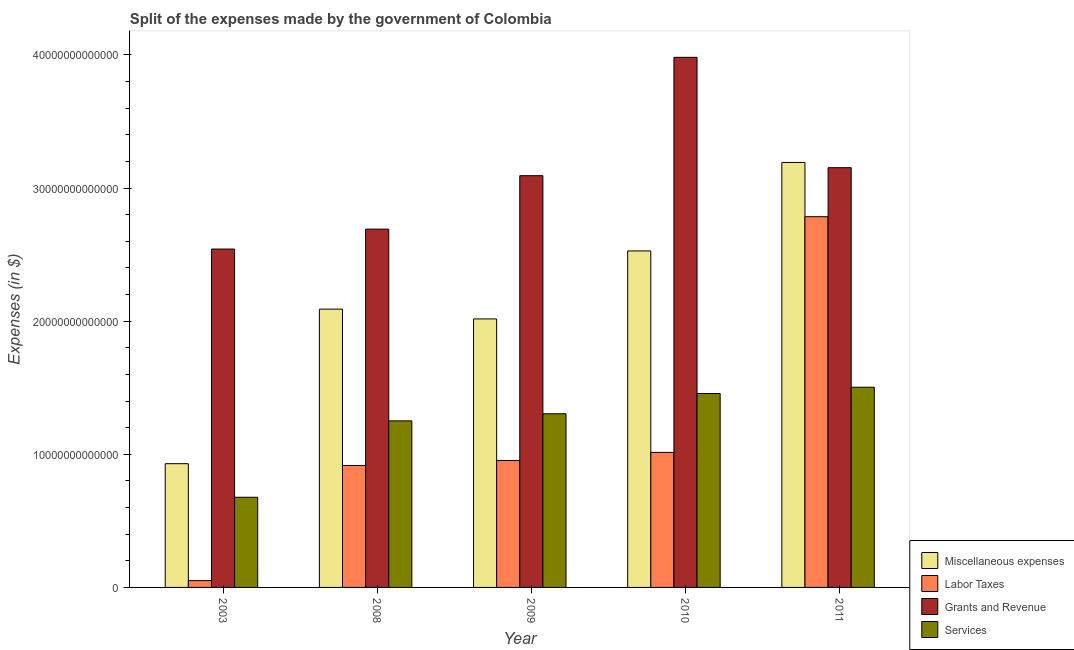How many bars are there on the 1st tick from the left?
Provide a succinct answer. 4. How many bars are there on the 5th tick from the right?
Make the answer very short. 4. In how many cases, is the number of bars for a given year not equal to the number of legend labels?
Offer a very short reply. 0. What is the amount spent on grants and revenue in 2009?
Make the answer very short. 3.09e+13. Across all years, what is the maximum amount spent on labor taxes?
Keep it short and to the point. 2.78e+13. Across all years, what is the minimum amount spent on services?
Offer a terse response. 6.77e+12. In which year was the amount spent on grants and revenue maximum?
Offer a terse response. 2010. In which year was the amount spent on miscellaneous expenses minimum?
Provide a succinct answer. 2003. What is the total amount spent on miscellaneous expenses in the graph?
Ensure brevity in your answer.  1.08e+14. What is the difference between the amount spent on services in 2003 and that in 2011?
Your answer should be very brief. -8.27e+12. What is the difference between the amount spent on miscellaneous expenses in 2008 and the amount spent on grants and revenue in 2003?
Your answer should be compact. 1.16e+13. What is the average amount spent on grants and revenue per year?
Give a very brief answer. 3.09e+13. In the year 2003, what is the difference between the amount spent on labor taxes and amount spent on grants and revenue?
Your answer should be very brief. 0. What is the ratio of the amount spent on labor taxes in 2008 to that in 2009?
Ensure brevity in your answer.  0.96. Is the amount spent on miscellaneous expenses in 2003 less than that in 2011?
Provide a succinct answer. Yes. What is the difference between the highest and the second highest amount spent on miscellaneous expenses?
Your response must be concise. 6.65e+12. What is the difference between the highest and the lowest amount spent on grants and revenue?
Give a very brief answer. 1.44e+13. In how many years, is the amount spent on services greater than the average amount spent on services taken over all years?
Keep it short and to the point. 4. Is it the case that in every year, the sum of the amount spent on services and amount spent on labor taxes is greater than the sum of amount spent on miscellaneous expenses and amount spent on grants and revenue?
Your answer should be compact. No. What does the 4th bar from the left in 2009 represents?
Your response must be concise. Services. What does the 4th bar from the right in 2008 represents?
Keep it short and to the point. Miscellaneous expenses. How many bars are there?
Provide a short and direct response. 20. How many years are there in the graph?
Your answer should be very brief. 5. What is the difference between two consecutive major ticks on the Y-axis?
Provide a short and direct response. 1.00e+13. Does the graph contain any zero values?
Offer a terse response. No. Does the graph contain grids?
Offer a very short reply. No. Where does the legend appear in the graph?
Offer a terse response. Bottom right. How many legend labels are there?
Your response must be concise. 4. How are the legend labels stacked?
Offer a terse response. Vertical. What is the title of the graph?
Offer a very short reply. Split of the expenses made by the government of Colombia. What is the label or title of the Y-axis?
Provide a short and direct response. Expenses (in $). What is the Expenses (in $) of Miscellaneous expenses in 2003?
Provide a short and direct response. 9.30e+12. What is the Expenses (in $) of Labor Taxes in 2003?
Ensure brevity in your answer.  5.11e+11. What is the Expenses (in $) of Grants and Revenue in 2003?
Ensure brevity in your answer.  2.54e+13. What is the Expenses (in $) of Services in 2003?
Give a very brief answer. 6.77e+12. What is the Expenses (in $) in Miscellaneous expenses in 2008?
Offer a terse response. 2.09e+13. What is the Expenses (in $) in Labor Taxes in 2008?
Provide a short and direct response. 9.16e+12. What is the Expenses (in $) in Grants and Revenue in 2008?
Give a very brief answer. 2.69e+13. What is the Expenses (in $) in Services in 2008?
Your response must be concise. 1.25e+13. What is the Expenses (in $) of Miscellaneous expenses in 2009?
Your answer should be very brief. 2.02e+13. What is the Expenses (in $) of Labor Taxes in 2009?
Offer a very short reply. 9.54e+12. What is the Expenses (in $) of Grants and Revenue in 2009?
Keep it short and to the point. 3.09e+13. What is the Expenses (in $) in Services in 2009?
Provide a short and direct response. 1.30e+13. What is the Expenses (in $) of Miscellaneous expenses in 2010?
Provide a succinct answer. 2.53e+13. What is the Expenses (in $) in Labor Taxes in 2010?
Make the answer very short. 1.01e+13. What is the Expenses (in $) in Grants and Revenue in 2010?
Offer a very short reply. 3.98e+13. What is the Expenses (in $) of Services in 2010?
Your answer should be compact. 1.46e+13. What is the Expenses (in $) of Miscellaneous expenses in 2011?
Your response must be concise. 3.19e+13. What is the Expenses (in $) in Labor Taxes in 2011?
Keep it short and to the point. 2.78e+13. What is the Expenses (in $) of Grants and Revenue in 2011?
Provide a short and direct response. 3.15e+13. What is the Expenses (in $) of Services in 2011?
Your response must be concise. 1.50e+13. Across all years, what is the maximum Expenses (in $) in Miscellaneous expenses?
Your answer should be compact. 3.19e+13. Across all years, what is the maximum Expenses (in $) in Labor Taxes?
Your response must be concise. 2.78e+13. Across all years, what is the maximum Expenses (in $) of Grants and Revenue?
Give a very brief answer. 3.98e+13. Across all years, what is the maximum Expenses (in $) in Services?
Keep it short and to the point. 1.50e+13. Across all years, what is the minimum Expenses (in $) of Miscellaneous expenses?
Your answer should be compact. 9.30e+12. Across all years, what is the minimum Expenses (in $) in Labor Taxes?
Your response must be concise. 5.11e+11. Across all years, what is the minimum Expenses (in $) of Grants and Revenue?
Make the answer very short. 2.54e+13. Across all years, what is the minimum Expenses (in $) in Services?
Provide a succinct answer. 6.77e+12. What is the total Expenses (in $) in Miscellaneous expenses in the graph?
Your answer should be very brief. 1.08e+14. What is the total Expenses (in $) in Labor Taxes in the graph?
Make the answer very short. 5.72e+13. What is the total Expenses (in $) in Grants and Revenue in the graph?
Give a very brief answer. 1.55e+14. What is the total Expenses (in $) in Services in the graph?
Provide a succinct answer. 6.19e+13. What is the difference between the Expenses (in $) in Miscellaneous expenses in 2003 and that in 2008?
Ensure brevity in your answer.  -1.16e+13. What is the difference between the Expenses (in $) in Labor Taxes in 2003 and that in 2008?
Provide a short and direct response. -8.65e+12. What is the difference between the Expenses (in $) in Grants and Revenue in 2003 and that in 2008?
Provide a short and direct response. -1.50e+12. What is the difference between the Expenses (in $) in Services in 2003 and that in 2008?
Your answer should be very brief. -5.74e+12. What is the difference between the Expenses (in $) in Miscellaneous expenses in 2003 and that in 2009?
Your response must be concise. -1.09e+13. What is the difference between the Expenses (in $) in Labor Taxes in 2003 and that in 2009?
Keep it short and to the point. -9.03e+12. What is the difference between the Expenses (in $) of Grants and Revenue in 2003 and that in 2009?
Make the answer very short. -5.51e+12. What is the difference between the Expenses (in $) in Services in 2003 and that in 2009?
Give a very brief answer. -6.27e+12. What is the difference between the Expenses (in $) of Miscellaneous expenses in 2003 and that in 2010?
Offer a terse response. -1.60e+13. What is the difference between the Expenses (in $) of Labor Taxes in 2003 and that in 2010?
Offer a terse response. -9.63e+12. What is the difference between the Expenses (in $) in Grants and Revenue in 2003 and that in 2010?
Ensure brevity in your answer.  -1.44e+13. What is the difference between the Expenses (in $) of Services in 2003 and that in 2010?
Provide a short and direct response. -7.79e+12. What is the difference between the Expenses (in $) of Miscellaneous expenses in 2003 and that in 2011?
Make the answer very short. -2.26e+13. What is the difference between the Expenses (in $) of Labor Taxes in 2003 and that in 2011?
Make the answer very short. -2.73e+13. What is the difference between the Expenses (in $) in Grants and Revenue in 2003 and that in 2011?
Provide a succinct answer. -6.11e+12. What is the difference between the Expenses (in $) in Services in 2003 and that in 2011?
Provide a succinct answer. -8.27e+12. What is the difference between the Expenses (in $) of Miscellaneous expenses in 2008 and that in 2009?
Keep it short and to the point. 7.33e+11. What is the difference between the Expenses (in $) in Labor Taxes in 2008 and that in 2009?
Make the answer very short. -3.74e+11. What is the difference between the Expenses (in $) in Grants and Revenue in 2008 and that in 2009?
Keep it short and to the point. -4.01e+12. What is the difference between the Expenses (in $) in Services in 2008 and that in 2009?
Make the answer very short. -5.34e+11. What is the difference between the Expenses (in $) in Miscellaneous expenses in 2008 and that in 2010?
Provide a short and direct response. -4.37e+12. What is the difference between the Expenses (in $) in Labor Taxes in 2008 and that in 2010?
Offer a terse response. -9.82e+11. What is the difference between the Expenses (in $) in Grants and Revenue in 2008 and that in 2010?
Make the answer very short. -1.29e+13. What is the difference between the Expenses (in $) in Services in 2008 and that in 2010?
Your answer should be very brief. -2.06e+12. What is the difference between the Expenses (in $) of Miscellaneous expenses in 2008 and that in 2011?
Make the answer very short. -1.10e+13. What is the difference between the Expenses (in $) of Labor Taxes in 2008 and that in 2011?
Your answer should be compact. -1.87e+13. What is the difference between the Expenses (in $) in Grants and Revenue in 2008 and that in 2011?
Your answer should be very brief. -4.61e+12. What is the difference between the Expenses (in $) of Services in 2008 and that in 2011?
Provide a succinct answer. -2.53e+12. What is the difference between the Expenses (in $) of Miscellaneous expenses in 2009 and that in 2010?
Ensure brevity in your answer.  -5.11e+12. What is the difference between the Expenses (in $) in Labor Taxes in 2009 and that in 2010?
Offer a very short reply. -6.08e+11. What is the difference between the Expenses (in $) of Grants and Revenue in 2009 and that in 2010?
Make the answer very short. -8.89e+12. What is the difference between the Expenses (in $) of Services in 2009 and that in 2010?
Give a very brief answer. -1.52e+12. What is the difference between the Expenses (in $) of Miscellaneous expenses in 2009 and that in 2011?
Give a very brief answer. -1.18e+13. What is the difference between the Expenses (in $) in Labor Taxes in 2009 and that in 2011?
Ensure brevity in your answer.  -1.83e+13. What is the difference between the Expenses (in $) of Grants and Revenue in 2009 and that in 2011?
Your answer should be very brief. -6.01e+11. What is the difference between the Expenses (in $) in Services in 2009 and that in 2011?
Your answer should be very brief. -1.99e+12. What is the difference between the Expenses (in $) in Miscellaneous expenses in 2010 and that in 2011?
Make the answer very short. -6.65e+12. What is the difference between the Expenses (in $) of Labor Taxes in 2010 and that in 2011?
Your answer should be very brief. -1.77e+13. What is the difference between the Expenses (in $) in Grants and Revenue in 2010 and that in 2011?
Make the answer very short. 8.29e+12. What is the difference between the Expenses (in $) in Services in 2010 and that in 2011?
Give a very brief answer. -4.73e+11. What is the difference between the Expenses (in $) of Miscellaneous expenses in 2003 and the Expenses (in $) of Labor Taxes in 2008?
Make the answer very short. 1.33e+11. What is the difference between the Expenses (in $) of Miscellaneous expenses in 2003 and the Expenses (in $) of Grants and Revenue in 2008?
Give a very brief answer. -1.76e+13. What is the difference between the Expenses (in $) of Miscellaneous expenses in 2003 and the Expenses (in $) of Services in 2008?
Offer a very short reply. -3.22e+12. What is the difference between the Expenses (in $) in Labor Taxes in 2003 and the Expenses (in $) in Grants and Revenue in 2008?
Your response must be concise. -2.64e+13. What is the difference between the Expenses (in $) of Labor Taxes in 2003 and the Expenses (in $) of Services in 2008?
Provide a short and direct response. -1.20e+13. What is the difference between the Expenses (in $) of Grants and Revenue in 2003 and the Expenses (in $) of Services in 2008?
Provide a short and direct response. 1.29e+13. What is the difference between the Expenses (in $) of Miscellaneous expenses in 2003 and the Expenses (in $) of Labor Taxes in 2009?
Provide a short and direct response. -2.41e+11. What is the difference between the Expenses (in $) in Miscellaneous expenses in 2003 and the Expenses (in $) in Grants and Revenue in 2009?
Your answer should be compact. -2.16e+13. What is the difference between the Expenses (in $) in Miscellaneous expenses in 2003 and the Expenses (in $) in Services in 2009?
Make the answer very short. -3.75e+12. What is the difference between the Expenses (in $) in Labor Taxes in 2003 and the Expenses (in $) in Grants and Revenue in 2009?
Your response must be concise. -3.04e+13. What is the difference between the Expenses (in $) in Labor Taxes in 2003 and the Expenses (in $) in Services in 2009?
Offer a very short reply. -1.25e+13. What is the difference between the Expenses (in $) of Grants and Revenue in 2003 and the Expenses (in $) of Services in 2009?
Ensure brevity in your answer.  1.24e+13. What is the difference between the Expenses (in $) of Miscellaneous expenses in 2003 and the Expenses (in $) of Labor Taxes in 2010?
Provide a short and direct response. -8.49e+11. What is the difference between the Expenses (in $) of Miscellaneous expenses in 2003 and the Expenses (in $) of Grants and Revenue in 2010?
Your answer should be very brief. -3.05e+13. What is the difference between the Expenses (in $) in Miscellaneous expenses in 2003 and the Expenses (in $) in Services in 2010?
Your answer should be very brief. -5.27e+12. What is the difference between the Expenses (in $) of Labor Taxes in 2003 and the Expenses (in $) of Grants and Revenue in 2010?
Your answer should be compact. -3.93e+13. What is the difference between the Expenses (in $) in Labor Taxes in 2003 and the Expenses (in $) in Services in 2010?
Your answer should be compact. -1.41e+13. What is the difference between the Expenses (in $) of Grants and Revenue in 2003 and the Expenses (in $) of Services in 2010?
Give a very brief answer. 1.09e+13. What is the difference between the Expenses (in $) of Miscellaneous expenses in 2003 and the Expenses (in $) of Labor Taxes in 2011?
Provide a short and direct response. -1.86e+13. What is the difference between the Expenses (in $) in Miscellaneous expenses in 2003 and the Expenses (in $) in Grants and Revenue in 2011?
Your answer should be compact. -2.22e+13. What is the difference between the Expenses (in $) of Miscellaneous expenses in 2003 and the Expenses (in $) of Services in 2011?
Make the answer very short. -5.74e+12. What is the difference between the Expenses (in $) in Labor Taxes in 2003 and the Expenses (in $) in Grants and Revenue in 2011?
Your response must be concise. -3.10e+13. What is the difference between the Expenses (in $) of Labor Taxes in 2003 and the Expenses (in $) of Services in 2011?
Keep it short and to the point. -1.45e+13. What is the difference between the Expenses (in $) of Grants and Revenue in 2003 and the Expenses (in $) of Services in 2011?
Ensure brevity in your answer.  1.04e+13. What is the difference between the Expenses (in $) of Miscellaneous expenses in 2008 and the Expenses (in $) of Labor Taxes in 2009?
Make the answer very short. 1.14e+13. What is the difference between the Expenses (in $) in Miscellaneous expenses in 2008 and the Expenses (in $) in Grants and Revenue in 2009?
Provide a short and direct response. -1.00e+13. What is the difference between the Expenses (in $) of Miscellaneous expenses in 2008 and the Expenses (in $) of Services in 2009?
Your answer should be compact. 7.86e+12. What is the difference between the Expenses (in $) in Labor Taxes in 2008 and the Expenses (in $) in Grants and Revenue in 2009?
Provide a succinct answer. -2.18e+13. What is the difference between the Expenses (in $) in Labor Taxes in 2008 and the Expenses (in $) in Services in 2009?
Keep it short and to the point. -3.88e+12. What is the difference between the Expenses (in $) of Grants and Revenue in 2008 and the Expenses (in $) of Services in 2009?
Provide a short and direct response. 1.39e+13. What is the difference between the Expenses (in $) in Miscellaneous expenses in 2008 and the Expenses (in $) in Labor Taxes in 2010?
Your answer should be compact. 1.08e+13. What is the difference between the Expenses (in $) of Miscellaneous expenses in 2008 and the Expenses (in $) of Grants and Revenue in 2010?
Your response must be concise. -1.89e+13. What is the difference between the Expenses (in $) of Miscellaneous expenses in 2008 and the Expenses (in $) of Services in 2010?
Your answer should be very brief. 6.34e+12. What is the difference between the Expenses (in $) in Labor Taxes in 2008 and the Expenses (in $) in Grants and Revenue in 2010?
Provide a short and direct response. -3.07e+13. What is the difference between the Expenses (in $) in Labor Taxes in 2008 and the Expenses (in $) in Services in 2010?
Ensure brevity in your answer.  -5.41e+12. What is the difference between the Expenses (in $) of Grants and Revenue in 2008 and the Expenses (in $) of Services in 2010?
Offer a terse response. 1.23e+13. What is the difference between the Expenses (in $) in Miscellaneous expenses in 2008 and the Expenses (in $) in Labor Taxes in 2011?
Offer a terse response. -6.94e+12. What is the difference between the Expenses (in $) in Miscellaneous expenses in 2008 and the Expenses (in $) in Grants and Revenue in 2011?
Keep it short and to the point. -1.06e+13. What is the difference between the Expenses (in $) of Miscellaneous expenses in 2008 and the Expenses (in $) of Services in 2011?
Provide a short and direct response. 5.86e+12. What is the difference between the Expenses (in $) in Labor Taxes in 2008 and the Expenses (in $) in Grants and Revenue in 2011?
Ensure brevity in your answer.  -2.24e+13. What is the difference between the Expenses (in $) of Labor Taxes in 2008 and the Expenses (in $) of Services in 2011?
Your response must be concise. -5.88e+12. What is the difference between the Expenses (in $) of Grants and Revenue in 2008 and the Expenses (in $) of Services in 2011?
Provide a short and direct response. 1.19e+13. What is the difference between the Expenses (in $) in Miscellaneous expenses in 2009 and the Expenses (in $) in Labor Taxes in 2010?
Your response must be concise. 1.00e+13. What is the difference between the Expenses (in $) in Miscellaneous expenses in 2009 and the Expenses (in $) in Grants and Revenue in 2010?
Ensure brevity in your answer.  -1.96e+13. What is the difference between the Expenses (in $) in Miscellaneous expenses in 2009 and the Expenses (in $) in Services in 2010?
Make the answer very short. 5.60e+12. What is the difference between the Expenses (in $) of Labor Taxes in 2009 and the Expenses (in $) of Grants and Revenue in 2010?
Your answer should be very brief. -3.03e+13. What is the difference between the Expenses (in $) of Labor Taxes in 2009 and the Expenses (in $) of Services in 2010?
Your answer should be compact. -5.03e+12. What is the difference between the Expenses (in $) of Grants and Revenue in 2009 and the Expenses (in $) of Services in 2010?
Provide a succinct answer. 1.64e+13. What is the difference between the Expenses (in $) of Miscellaneous expenses in 2009 and the Expenses (in $) of Labor Taxes in 2011?
Make the answer very short. -7.68e+12. What is the difference between the Expenses (in $) in Miscellaneous expenses in 2009 and the Expenses (in $) in Grants and Revenue in 2011?
Offer a very short reply. -1.14e+13. What is the difference between the Expenses (in $) of Miscellaneous expenses in 2009 and the Expenses (in $) of Services in 2011?
Ensure brevity in your answer.  5.13e+12. What is the difference between the Expenses (in $) in Labor Taxes in 2009 and the Expenses (in $) in Grants and Revenue in 2011?
Ensure brevity in your answer.  -2.20e+13. What is the difference between the Expenses (in $) in Labor Taxes in 2009 and the Expenses (in $) in Services in 2011?
Your answer should be very brief. -5.50e+12. What is the difference between the Expenses (in $) of Grants and Revenue in 2009 and the Expenses (in $) of Services in 2011?
Offer a very short reply. 1.59e+13. What is the difference between the Expenses (in $) of Miscellaneous expenses in 2010 and the Expenses (in $) of Labor Taxes in 2011?
Offer a terse response. -2.57e+12. What is the difference between the Expenses (in $) in Miscellaneous expenses in 2010 and the Expenses (in $) in Grants and Revenue in 2011?
Provide a succinct answer. -6.25e+12. What is the difference between the Expenses (in $) in Miscellaneous expenses in 2010 and the Expenses (in $) in Services in 2011?
Your answer should be very brief. 1.02e+13. What is the difference between the Expenses (in $) of Labor Taxes in 2010 and the Expenses (in $) of Grants and Revenue in 2011?
Your answer should be compact. -2.14e+13. What is the difference between the Expenses (in $) of Labor Taxes in 2010 and the Expenses (in $) of Services in 2011?
Provide a succinct answer. -4.90e+12. What is the difference between the Expenses (in $) in Grants and Revenue in 2010 and the Expenses (in $) in Services in 2011?
Your response must be concise. 2.48e+13. What is the average Expenses (in $) in Miscellaneous expenses per year?
Your answer should be compact. 2.15e+13. What is the average Expenses (in $) of Labor Taxes per year?
Keep it short and to the point. 1.14e+13. What is the average Expenses (in $) of Grants and Revenue per year?
Provide a short and direct response. 3.09e+13. What is the average Expenses (in $) of Services per year?
Your response must be concise. 1.24e+13. In the year 2003, what is the difference between the Expenses (in $) in Miscellaneous expenses and Expenses (in $) in Labor Taxes?
Offer a terse response. 8.78e+12. In the year 2003, what is the difference between the Expenses (in $) of Miscellaneous expenses and Expenses (in $) of Grants and Revenue?
Give a very brief answer. -1.61e+13. In the year 2003, what is the difference between the Expenses (in $) of Miscellaneous expenses and Expenses (in $) of Services?
Offer a very short reply. 2.52e+12. In the year 2003, what is the difference between the Expenses (in $) of Labor Taxes and Expenses (in $) of Grants and Revenue?
Offer a very short reply. -2.49e+13. In the year 2003, what is the difference between the Expenses (in $) of Labor Taxes and Expenses (in $) of Services?
Your answer should be compact. -6.26e+12. In the year 2003, what is the difference between the Expenses (in $) in Grants and Revenue and Expenses (in $) in Services?
Make the answer very short. 1.86e+13. In the year 2008, what is the difference between the Expenses (in $) of Miscellaneous expenses and Expenses (in $) of Labor Taxes?
Give a very brief answer. 1.17e+13. In the year 2008, what is the difference between the Expenses (in $) of Miscellaneous expenses and Expenses (in $) of Grants and Revenue?
Your answer should be very brief. -6.01e+12. In the year 2008, what is the difference between the Expenses (in $) in Miscellaneous expenses and Expenses (in $) in Services?
Keep it short and to the point. 8.39e+12. In the year 2008, what is the difference between the Expenses (in $) in Labor Taxes and Expenses (in $) in Grants and Revenue?
Give a very brief answer. -1.78e+13. In the year 2008, what is the difference between the Expenses (in $) in Labor Taxes and Expenses (in $) in Services?
Make the answer very short. -3.35e+12. In the year 2008, what is the difference between the Expenses (in $) in Grants and Revenue and Expenses (in $) in Services?
Offer a very short reply. 1.44e+13. In the year 2009, what is the difference between the Expenses (in $) in Miscellaneous expenses and Expenses (in $) in Labor Taxes?
Your answer should be very brief. 1.06e+13. In the year 2009, what is the difference between the Expenses (in $) of Miscellaneous expenses and Expenses (in $) of Grants and Revenue?
Keep it short and to the point. -1.08e+13. In the year 2009, what is the difference between the Expenses (in $) in Miscellaneous expenses and Expenses (in $) in Services?
Offer a very short reply. 7.13e+12. In the year 2009, what is the difference between the Expenses (in $) in Labor Taxes and Expenses (in $) in Grants and Revenue?
Your answer should be compact. -2.14e+13. In the year 2009, what is the difference between the Expenses (in $) in Labor Taxes and Expenses (in $) in Services?
Your answer should be compact. -3.51e+12. In the year 2009, what is the difference between the Expenses (in $) in Grants and Revenue and Expenses (in $) in Services?
Keep it short and to the point. 1.79e+13. In the year 2010, what is the difference between the Expenses (in $) of Miscellaneous expenses and Expenses (in $) of Labor Taxes?
Provide a short and direct response. 1.51e+13. In the year 2010, what is the difference between the Expenses (in $) of Miscellaneous expenses and Expenses (in $) of Grants and Revenue?
Offer a terse response. -1.45e+13. In the year 2010, what is the difference between the Expenses (in $) in Miscellaneous expenses and Expenses (in $) in Services?
Keep it short and to the point. 1.07e+13. In the year 2010, what is the difference between the Expenses (in $) in Labor Taxes and Expenses (in $) in Grants and Revenue?
Your answer should be very brief. -2.97e+13. In the year 2010, what is the difference between the Expenses (in $) in Labor Taxes and Expenses (in $) in Services?
Keep it short and to the point. -4.42e+12. In the year 2010, what is the difference between the Expenses (in $) of Grants and Revenue and Expenses (in $) of Services?
Ensure brevity in your answer.  2.53e+13. In the year 2011, what is the difference between the Expenses (in $) in Miscellaneous expenses and Expenses (in $) in Labor Taxes?
Ensure brevity in your answer.  4.08e+12. In the year 2011, what is the difference between the Expenses (in $) of Miscellaneous expenses and Expenses (in $) of Grants and Revenue?
Make the answer very short. 3.94e+11. In the year 2011, what is the difference between the Expenses (in $) in Miscellaneous expenses and Expenses (in $) in Services?
Provide a succinct answer. 1.69e+13. In the year 2011, what is the difference between the Expenses (in $) in Labor Taxes and Expenses (in $) in Grants and Revenue?
Your answer should be compact. -3.68e+12. In the year 2011, what is the difference between the Expenses (in $) of Labor Taxes and Expenses (in $) of Services?
Offer a terse response. 1.28e+13. In the year 2011, what is the difference between the Expenses (in $) in Grants and Revenue and Expenses (in $) in Services?
Your answer should be very brief. 1.65e+13. What is the ratio of the Expenses (in $) in Miscellaneous expenses in 2003 to that in 2008?
Offer a terse response. 0.44. What is the ratio of the Expenses (in $) of Labor Taxes in 2003 to that in 2008?
Offer a very short reply. 0.06. What is the ratio of the Expenses (in $) of Grants and Revenue in 2003 to that in 2008?
Offer a very short reply. 0.94. What is the ratio of the Expenses (in $) of Services in 2003 to that in 2008?
Your answer should be compact. 0.54. What is the ratio of the Expenses (in $) of Miscellaneous expenses in 2003 to that in 2009?
Provide a succinct answer. 0.46. What is the ratio of the Expenses (in $) in Labor Taxes in 2003 to that in 2009?
Your response must be concise. 0.05. What is the ratio of the Expenses (in $) of Grants and Revenue in 2003 to that in 2009?
Your response must be concise. 0.82. What is the ratio of the Expenses (in $) in Services in 2003 to that in 2009?
Your answer should be very brief. 0.52. What is the ratio of the Expenses (in $) of Miscellaneous expenses in 2003 to that in 2010?
Ensure brevity in your answer.  0.37. What is the ratio of the Expenses (in $) of Labor Taxes in 2003 to that in 2010?
Your answer should be compact. 0.05. What is the ratio of the Expenses (in $) of Grants and Revenue in 2003 to that in 2010?
Your answer should be compact. 0.64. What is the ratio of the Expenses (in $) of Services in 2003 to that in 2010?
Provide a succinct answer. 0.46. What is the ratio of the Expenses (in $) in Miscellaneous expenses in 2003 to that in 2011?
Offer a terse response. 0.29. What is the ratio of the Expenses (in $) of Labor Taxes in 2003 to that in 2011?
Your answer should be very brief. 0.02. What is the ratio of the Expenses (in $) in Grants and Revenue in 2003 to that in 2011?
Give a very brief answer. 0.81. What is the ratio of the Expenses (in $) of Services in 2003 to that in 2011?
Provide a short and direct response. 0.45. What is the ratio of the Expenses (in $) of Miscellaneous expenses in 2008 to that in 2009?
Offer a terse response. 1.04. What is the ratio of the Expenses (in $) in Labor Taxes in 2008 to that in 2009?
Provide a succinct answer. 0.96. What is the ratio of the Expenses (in $) in Grants and Revenue in 2008 to that in 2009?
Make the answer very short. 0.87. What is the ratio of the Expenses (in $) of Services in 2008 to that in 2009?
Keep it short and to the point. 0.96. What is the ratio of the Expenses (in $) of Miscellaneous expenses in 2008 to that in 2010?
Offer a terse response. 0.83. What is the ratio of the Expenses (in $) of Labor Taxes in 2008 to that in 2010?
Offer a very short reply. 0.9. What is the ratio of the Expenses (in $) in Grants and Revenue in 2008 to that in 2010?
Ensure brevity in your answer.  0.68. What is the ratio of the Expenses (in $) of Services in 2008 to that in 2010?
Offer a very short reply. 0.86. What is the ratio of the Expenses (in $) in Miscellaneous expenses in 2008 to that in 2011?
Your answer should be very brief. 0.65. What is the ratio of the Expenses (in $) of Labor Taxes in 2008 to that in 2011?
Your answer should be compact. 0.33. What is the ratio of the Expenses (in $) of Grants and Revenue in 2008 to that in 2011?
Make the answer very short. 0.85. What is the ratio of the Expenses (in $) of Services in 2008 to that in 2011?
Give a very brief answer. 0.83. What is the ratio of the Expenses (in $) of Miscellaneous expenses in 2009 to that in 2010?
Provide a succinct answer. 0.8. What is the ratio of the Expenses (in $) of Grants and Revenue in 2009 to that in 2010?
Your answer should be very brief. 0.78. What is the ratio of the Expenses (in $) in Services in 2009 to that in 2010?
Make the answer very short. 0.9. What is the ratio of the Expenses (in $) in Miscellaneous expenses in 2009 to that in 2011?
Your response must be concise. 0.63. What is the ratio of the Expenses (in $) of Labor Taxes in 2009 to that in 2011?
Offer a very short reply. 0.34. What is the ratio of the Expenses (in $) in Grants and Revenue in 2009 to that in 2011?
Your answer should be compact. 0.98. What is the ratio of the Expenses (in $) of Services in 2009 to that in 2011?
Offer a terse response. 0.87. What is the ratio of the Expenses (in $) in Miscellaneous expenses in 2010 to that in 2011?
Provide a succinct answer. 0.79. What is the ratio of the Expenses (in $) in Labor Taxes in 2010 to that in 2011?
Your answer should be compact. 0.36. What is the ratio of the Expenses (in $) in Grants and Revenue in 2010 to that in 2011?
Your answer should be compact. 1.26. What is the ratio of the Expenses (in $) of Services in 2010 to that in 2011?
Your response must be concise. 0.97. What is the difference between the highest and the second highest Expenses (in $) of Miscellaneous expenses?
Your answer should be very brief. 6.65e+12. What is the difference between the highest and the second highest Expenses (in $) of Labor Taxes?
Offer a very short reply. 1.77e+13. What is the difference between the highest and the second highest Expenses (in $) of Grants and Revenue?
Offer a terse response. 8.29e+12. What is the difference between the highest and the second highest Expenses (in $) in Services?
Make the answer very short. 4.73e+11. What is the difference between the highest and the lowest Expenses (in $) of Miscellaneous expenses?
Provide a short and direct response. 2.26e+13. What is the difference between the highest and the lowest Expenses (in $) in Labor Taxes?
Your answer should be very brief. 2.73e+13. What is the difference between the highest and the lowest Expenses (in $) in Grants and Revenue?
Offer a terse response. 1.44e+13. What is the difference between the highest and the lowest Expenses (in $) in Services?
Keep it short and to the point. 8.27e+12. 